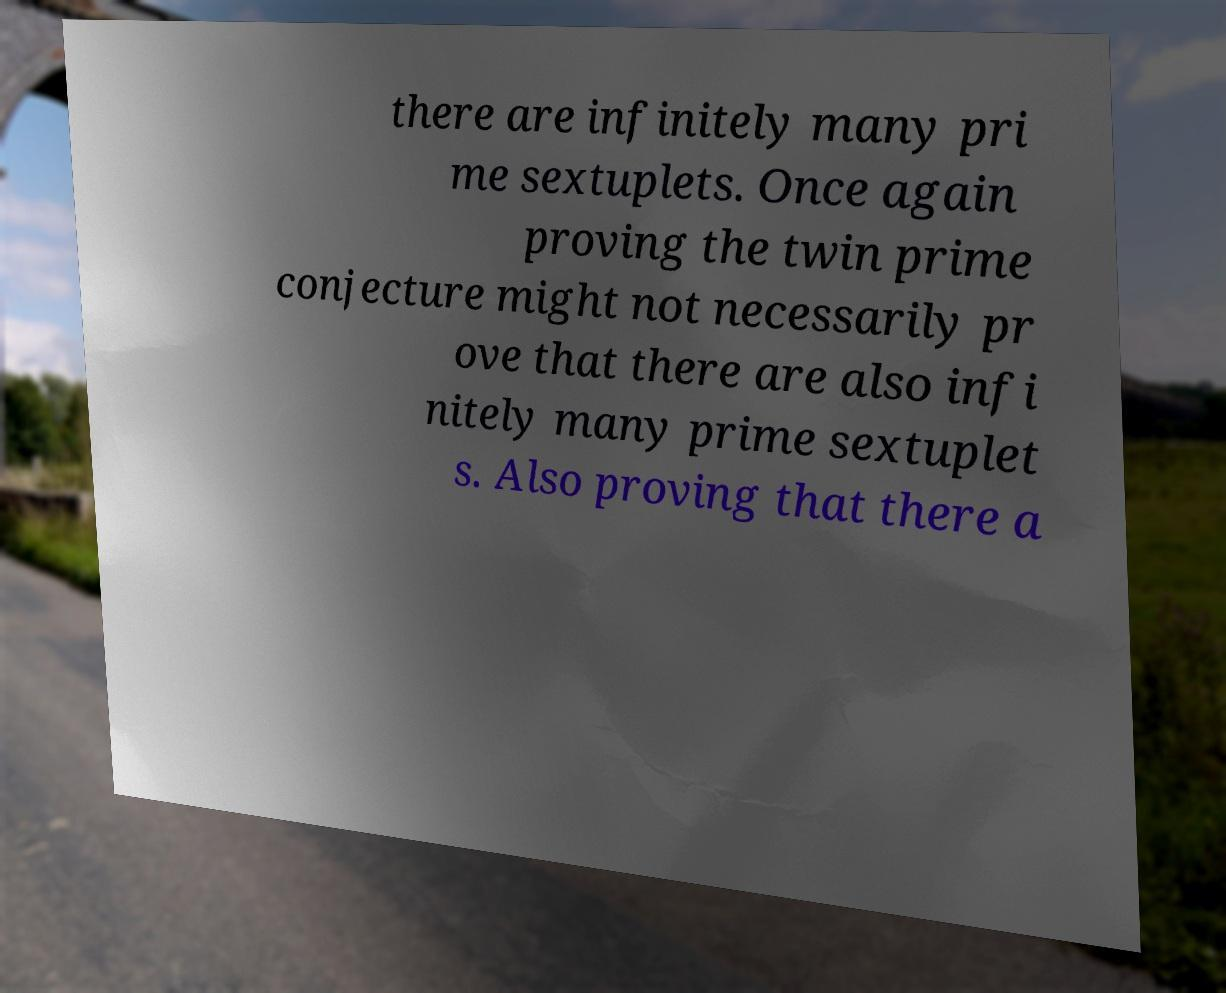Please identify and transcribe the text found in this image. there are infinitely many pri me sextuplets. Once again proving the twin prime conjecture might not necessarily pr ove that there are also infi nitely many prime sextuplet s. Also proving that there a 